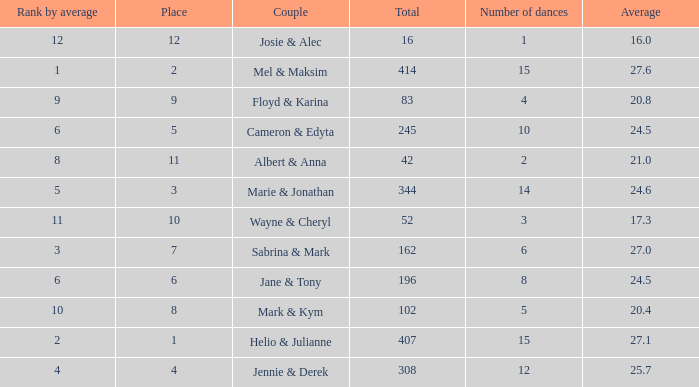What is the average place for a couple with the rank by average of 9 and total smaller than 83? None. 